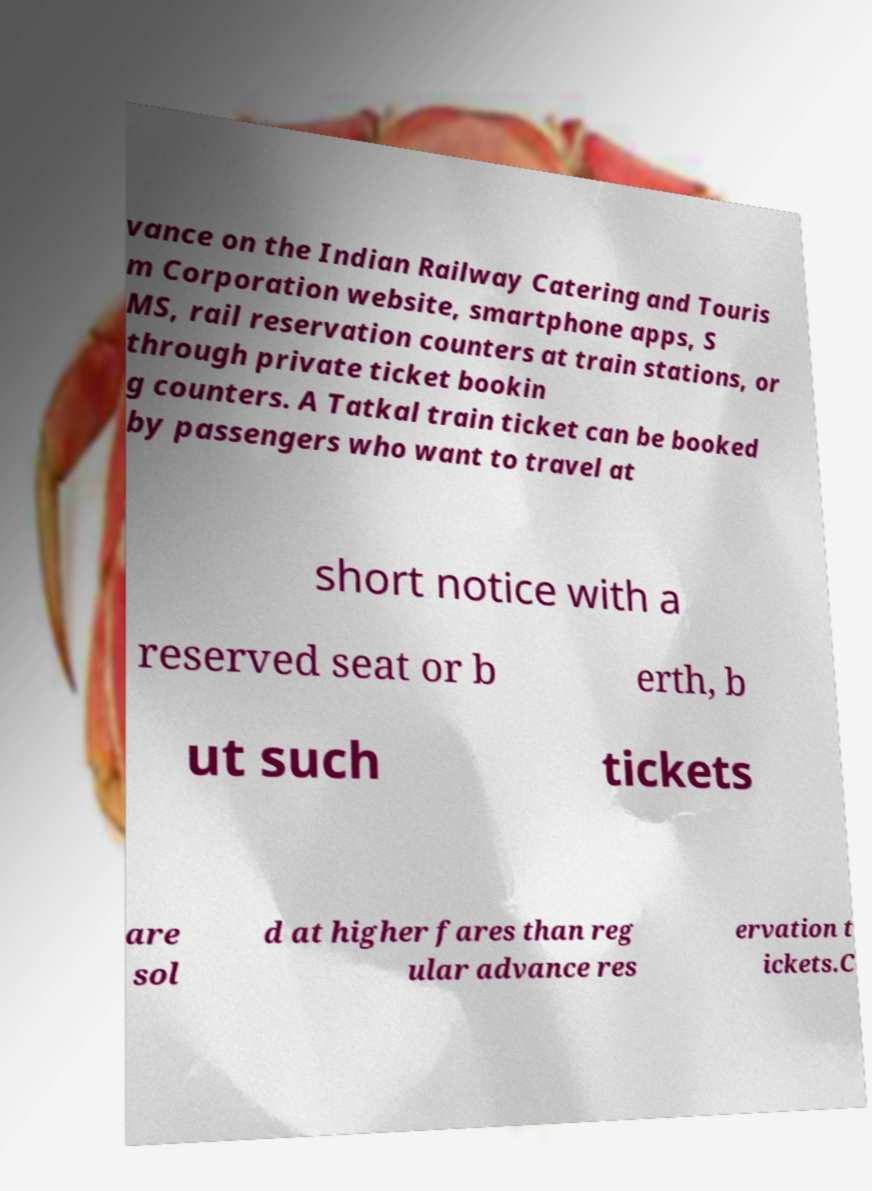I need the written content from this picture converted into text. Can you do that? vance on the Indian Railway Catering and Touris m Corporation website, smartphone apps, S MS, rail reservation counters at train stations, or through private ticket bookin g counters. A Tatkal train ticket can be booked by passengers who want to travel at short notice with a reserved seat or b erth, b ut such tickets are sol d at higher fares than reg ular advance res ervation t ickets.C 